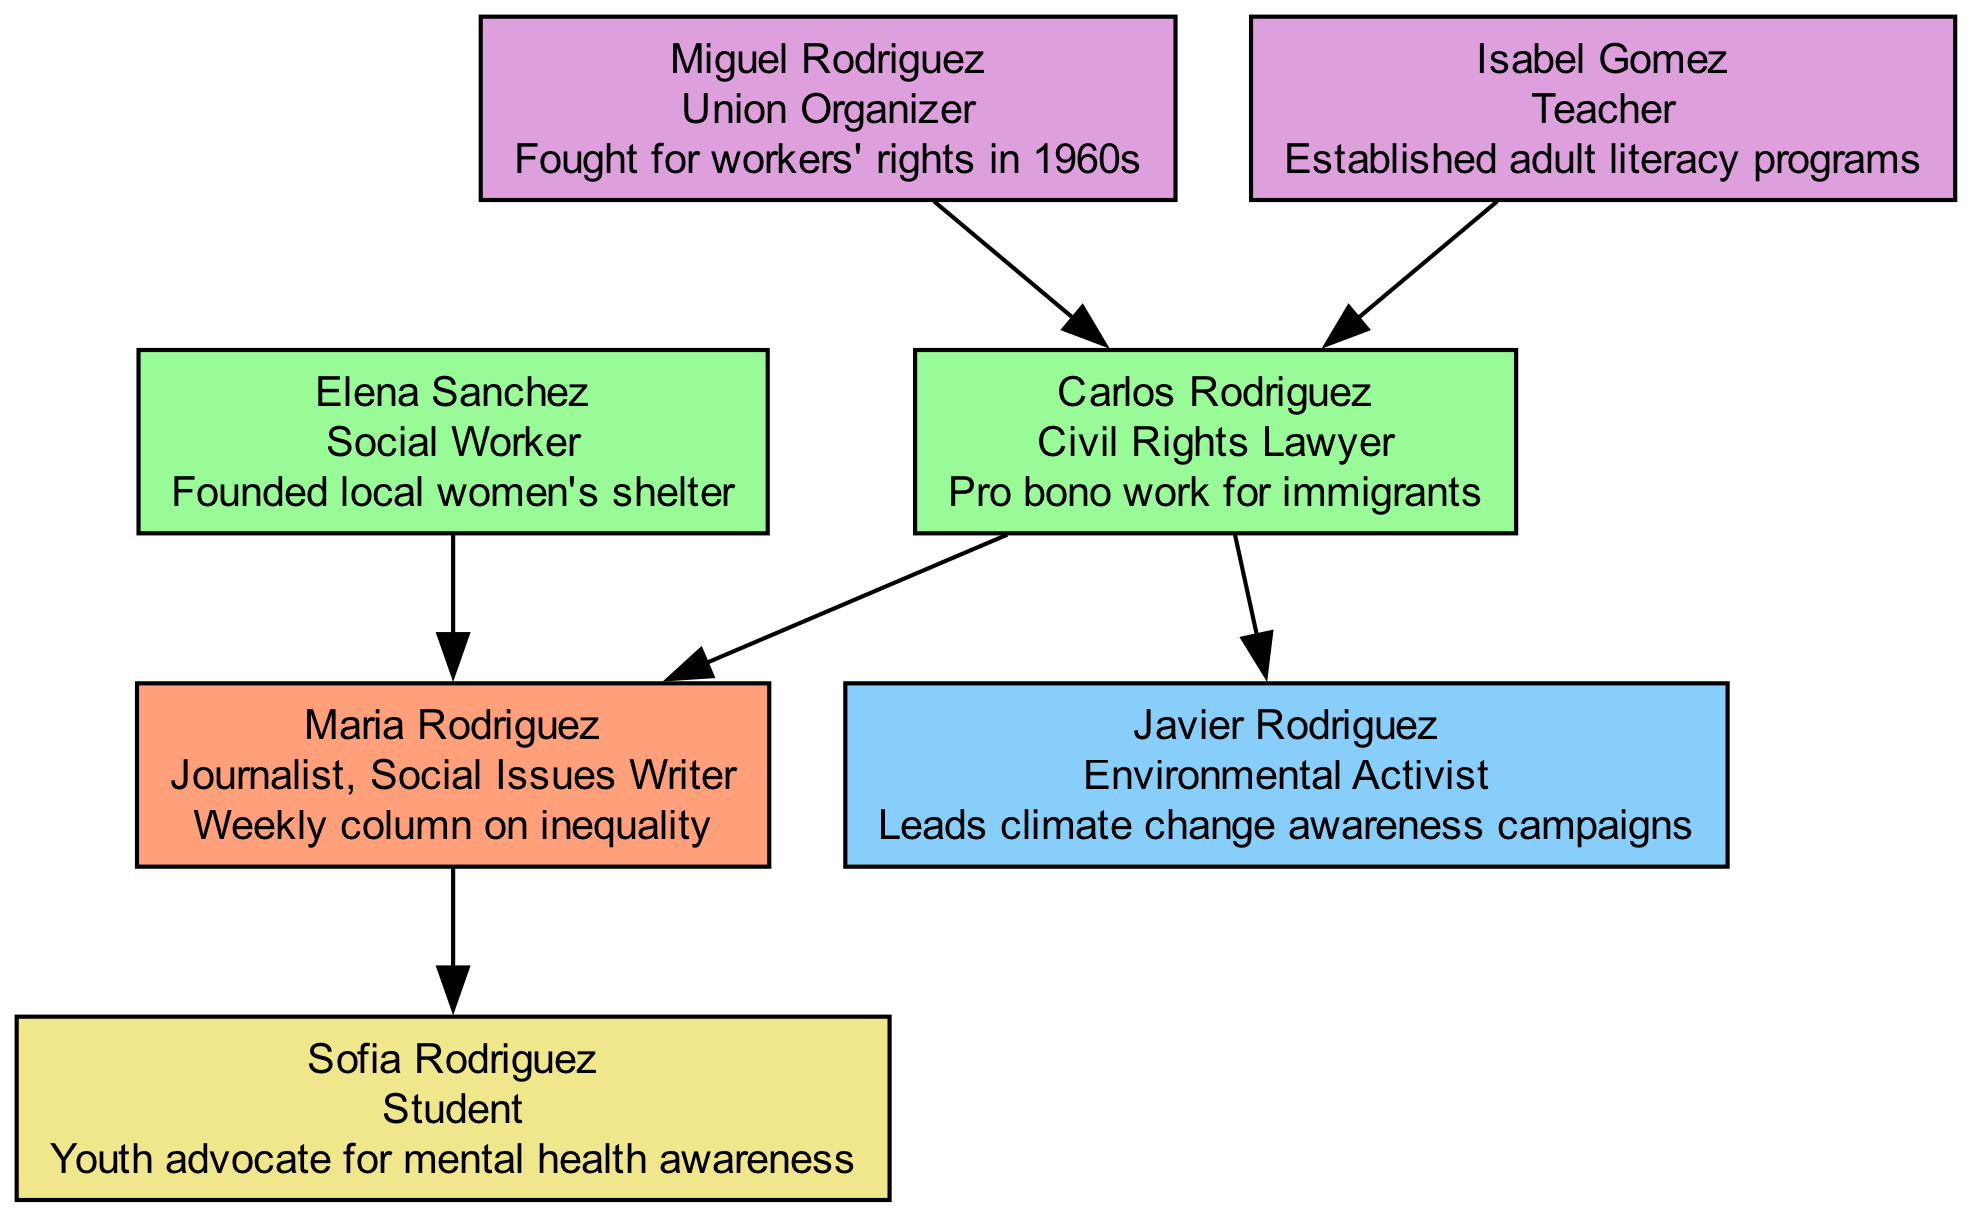What is the occupation of Maria Rodriguez? The diagram identifies Maria Rodriguez as a "Journalist, Social Issues Writer" directly linked to the root of the family tree.
Answer: Journalist, Social Issues Writer Who are the parents of Maria Rodriguez? The parents are listed directly beneath Maria in the diagram, showing Carlos Rodriguez and Elena Sanchez.
Answer: Carlos Rodriguez, Elena Sanchez How many siblings does Maria Rodriguez have? The sibling section in the diagram shows one sibling, Javier Rodriguez, therefore there is a total of one sibling for Maria.
Answer: 1 What social cause did Carlos Rodriguez contribute to? Looking at the details in the parents' section, Carlos Rodriguez is noted for his contribution of "Pro bono work for immigrants."
Answer: Pro bono work for immigrants Which family member established adult literacy programs? The grandparents' section identifies Isabel Gomez as the one who established adult literacy programs, making her the family member tied to this cause.
Answer: Isabel Gomez What occupation does Sofia Rodriguez have? The children section of the diagram specifies that Sofia Rodriguez is a "Student," which is her current occupation.
Answer: Student What is Javier Rodriguez known for? By consulting the siblings section, Javier Rodriguez is identified as an "Environmental Activist" who leads climate change awareness campaigns.
Answer: Environmental Activist Which grandparent was a Union Organizer? In the grandparents’ section, Miguel Rodriguez is listed as a "Union Organizer," showing his role in fighting for workers' rights.
Answer: Miguel Rodriguez How many nodes represent the family members in total? The diagram includes nodes for Maria, her parents, her sibling, her grandparents, and her child. Counting these gives a total of 7 nodes.
Answer: 7 